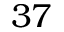<formula> <loc_0><loc_0><loc_500><loc_500>3 7</formula> 